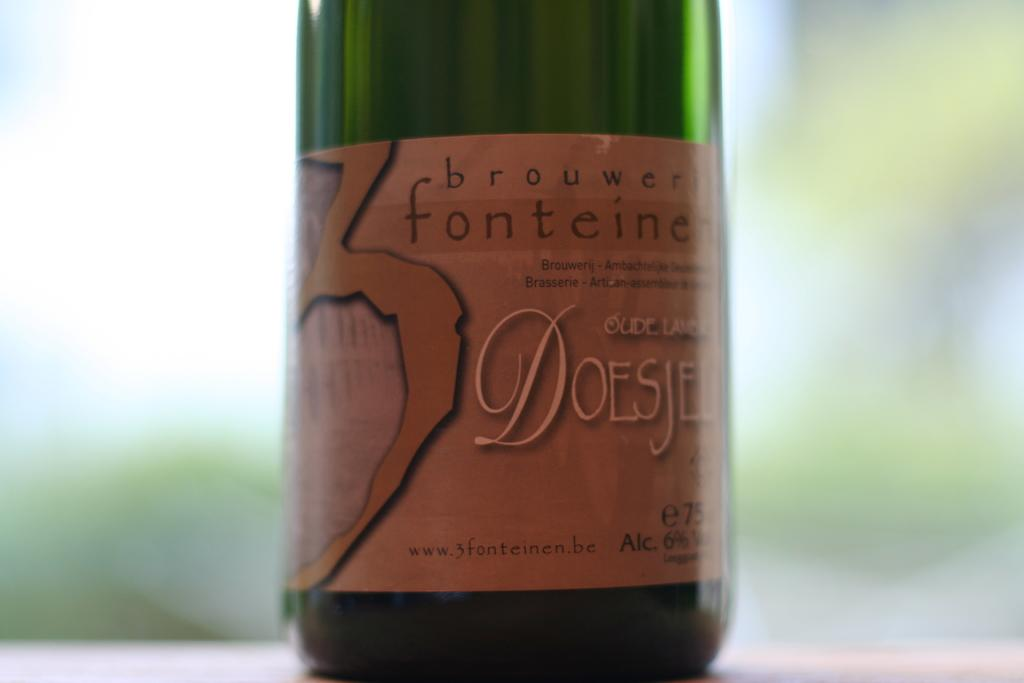<image>
Write a terse but informative summary of the picture. A green fonteine bottle that has a 6% alcohol content. 